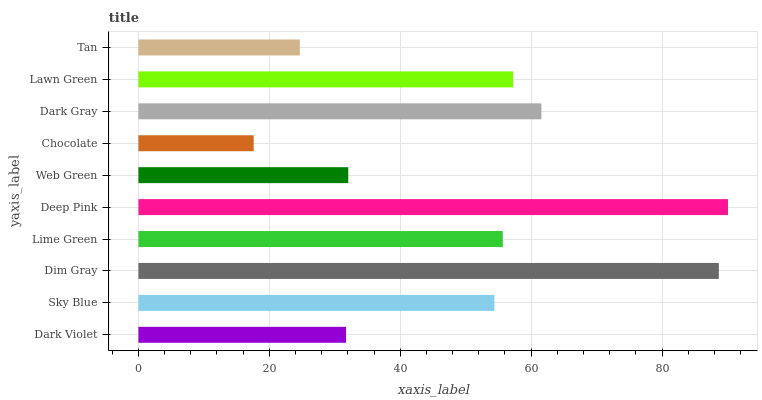Is Chocolate the minimum?
Answer yes or no. Yes. Is Deep Pink the maximum?
Answer yes or no. Yes. Is Sky Blue the minimum?
Answer yes or no. No. Is Sky Blue the maximum?
Answer yes or no. No. Is Sky Blue greater than Dark Violet?
Answer yes or no. Yes. Is Dark Violet less than Sky Blue?
Answer yes or no. Yes. Is Dark Violet greater than Sky Blue?
Answer yes or no. No. Is Sky Blue less than Dark Violet?
Answer yes or no. No. Is Lime Green the high median?
Answer yes or no. Yes. Is Sky Blue the low median?
Answer yes or no. Yes. Is Web Green the high median?
Answer yes or no. No. Is Lime Green the low median?
Answer yes or no. No. 